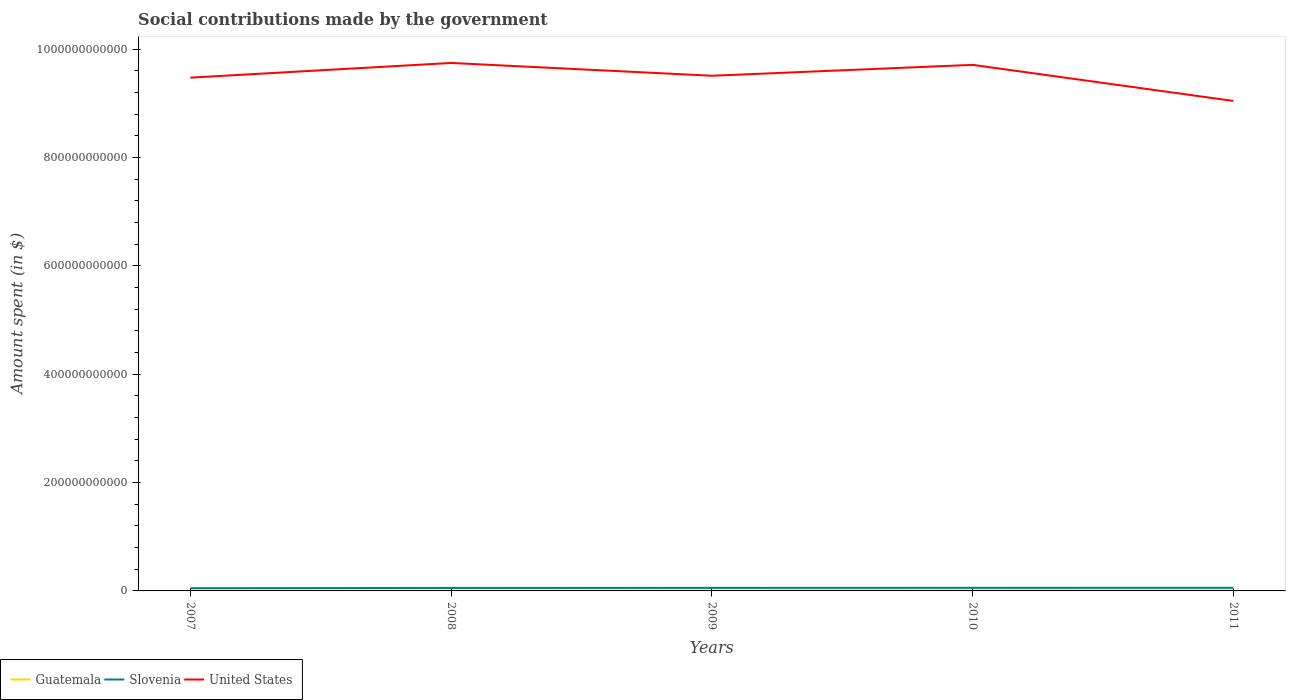How many different coloured lines are there?
Your answer should be compact. 3. Across all years, what is the maximum amount spent on social contributions in Guatemala?
Your response must be concise. 6.59e+08. In which year was the amount spent on social contributions in Slovenia maximum?
Your answer should be very brief. 2007. What is the total amount spent on social contributions in United States in the graph?
Provide a short and direct response. 6.66e+1. What is the difference between the highest and the second highest amount spent on social contributions in Guatemala?
Provide a short and direct response. 5.56e+08. Is the amount spent on social contributions in Slovenia strictly greater than the amount spent on social contributions in Guatemala over the years?
Give a very brief answer. No. What is the difference between two consecutive major ticks on the Y-axis?
Your answer should be compact. 2.00e+11. Does the graph contain any zero values?
Keep it short and to the point. No. Does the graph contain grids?
Provide a succinct answer. No. Where does the legend appear in the graph?
Make the answer very short. Bottom left. How are the legend labels stacked?
Your response must be concise. Horizontal. What is the title of the graph?
Provide a short and direct response. Social contributions made by the government. Does "Latin America(all income levels)" appear as one of the legend labels in the graph?
Your response must be concise. No. What is the label or title of the Y-axis?
Provide a short and direct response. Amount spent (in $). What is the Amount spent (in $) in Guatemala in 2007?
Provide a succinct answer. 6.59e+08. What is the Amount spent (in $) in Slovenia in 2007?
Your answer should be compact. 5.00e+09. What is the Amount spent (in $) in United States in 2007?
Ensure brevity in your answer.  9.47e+11. What is the Amount spent (in $) of Guatemala in 2008?
Provide a short and direct response. 7.46e+08. What is the Amount spent (in $) in Slovenia in 2008?
Your answer should be very brief. 5.53e+09. What is the Amount spent (in $) in United States in 2008?
Provide a short and direct response. 9.74e+11. What is the Amount spent (in $) of Guatemala in 2009?
Your answer should be compact. 9.22e+08. What is the Amount spent (in $) of Slovenia in 2009?
Provide a short and direct response. 5.64e+09. What is the Amount spent (in $) in United States in 2009?
Provide a succinct answer. 9.51e+11. What is the Amount spent (in $) in Guatemala in 2010?
Give a very brief answer. 1.07e+09. What is the Amount spent (in $) in Slovenia in 2010?
Offer a very short reply. 5.74e+09. What is the Amount spent (in $) in United States in 2010?
Provide a succinct answer. 9.71e+11. What is the Amount spent (in $) in Guatemala in 2011?
Make the answer very short. 1.21e+09. What is the Amount spent (in $) of Slovenia in 2011?
Ensure brevity in your answer.  5.78e+09. What is the Amount spent (in $) of United States in 2011?
Your answer should be compact. 9.04e+11. Across all years, what is the maximum Amount spent (in $) in Guatemala?
Ensure brevity in your answer.  1.21e+09. Across all years, what is the maximum Amount spent (in $) of Slovenia?
Give a very brief answer. 5.78e+09. Across all years, what is the maximum Amount spent (in $) in United States?
Offer a terse response. 9.74e+11. Across all years, what is the minimum Amount spent (in $) in Guatemala?
Your response must be concise. 6.59e+08. Across all years, what is the minimum Amount spent (in $) of Slovenia?
Offer a very short reply. 5.00e+09. Across all years, what is the minimum Amount spent (in $) in United States?
Ensure brevity in your answer.  9.04e+11. What is the total Amount spent (in $) of Guatemala in the graph?
Offer a very short reply. 4.61e+09. What is the total Amount spent (in $) in Slovenia in the graph?
Your response must be concise. 2.77e+1. What is the total Amount spent (in $) in United States in the graph?
Keep it short and to the point. 4.75e+12. What is the difference between the Amount spent (in $) of Guatemala in 2007 and that in 2008?
Offer a terse response. -8.79e+07. What is the difference between the Amount spent (in $) in Slovenia in 2007 and that in 2008?
Give a very brief answer. -5.23e+08. What is the difference between the Amount spent (in $) of United States in 2007 and that in 2008?
Your response must be concise. -2.71e+1. What is the difference between the Amount spent (in $) in Guatemala in 2007 and that in 2009?
Provide a succinct answer. -2.64e+08. What is the difference between the Amount spent (in $) of Slovenia in 2007 and that in 2009?
Provide a short and direct response. -6.35e+08. What is the difference between the Amount spent (in $) in United States in 2007 and that in 2009?
Your answer should be very brief. -3.50e+09. What is the difference between the Amount spent (in $) in Guatemala in 2007 and that in 2010?
Make the answer very short. -4.10e+08. What is the difference between the Amount spent (in $) in Slovenia in 2007 and that in 2010?
Offer a terse response. -7.35e+08. What is the difference between the Amount spent (in $) of United States in 2007 and that in 2010?
Your answer should be compact. -2.36e+1. What is the difference between the Amount spent (in $) in Guatemala in 2007 and that in 2011?
Give a very brief answer. -5.56e+08. What is the difference between the Amount spent (in $) of Slovenia in 2007 and that in 2011?
Make the answer very short. -7.79e+08. What is the difference between the Amount spent (in $) in United States in 2007 and that in 2011?
Your response must be concise. 4.30e+1. What is the difference between the Amount spent (in $) of Guatemala in 2008 and that in 2009?
Provide a succinct answer. -1.76e+08. What is the difference between the Amount spent (in $) of Slovenia in 2008 and that in 2009?
Give a very brief answer. -1.11e+08. What is the difference between the Amount spent (in $) in United States in 2008 and that in 2009?
Offer a very short reply. 2.36e+1. What is the difference between the Amount spent (in $) in Guatemala in 2008 and that in 2010?
Your answer should be compact. -3.23e+08. What is the difference between the Amount spent (in $) in Slovenia in 2008 and that in 2010?
Your answer should be very brief. -2.11e+08. What is the difference between the Amount spent (in $) of United States in 2008 and that in 2010?
Your answer should be compact. 3.50e+09. What is the difference between the Amount spent (in $) in Guatemala in 2008 and that in 2011?
Your response must be concise. -4.68e+08. What is the difference between the Amount spent (in $) in Slovenia in 2008 and that in 2011?
Your answer should be very brief. -2.56e+08. What is the difference between the Amount spent (in $) in United States in 2008 and that in 2011?
Make the answer very short. 7.01e+1. What is the difference between the Amount spent (in $) of Guatemala in 2009 and that in 2010?
Your response must be concise. -1.47e+08. What is the difference between the Amount spent (in $) in Slovenia in 2009 and that in 2010?
Provide a short and direct response. -9.99e+07. What is the difference between the Amount spent (in $) of United States in 2009 and that in 2010?
Provide a short and direct response. -2.01e+1. What is the difference between the Amount spent (in $) in Guatemala in 2009 and that in 2011?
Your response must be concise. -2.92e+08. What is the difference between the Amount spent (in $) in Slovenia in 2009 and that in 2011?
Provide a short and direct response. -1.44e+08. What is the difference between the Amount spent (in $) in United States in 2009 and that in 2011?
Your answer should be compact. 4.65e+1. What is the difference between the Amount spent (in $) of Guatemala in 2010 and that in 2011?
Keep it short and to the point. -1.45e+08. What is the difference between the Amount spent (in $) in Slovenia in 2010 and that in 2011?
Your response must be concise. -4.46e+07. What is the difference between the Amount spent (in $) of United States in 2010 and that in 2011?
Keep it short and to the point. 6.66e+1. What is the difference between the Amount spent (in $) in Guatemala in 2007 and the Amount spent (in $) in Slovenia in 2008?
Make the answer very short. -4.87e+09. What is the difference between the Amount spent (in $) in Guatemala in 2007 and the Amount spent (in $) in United States in 2008?
Give a very brief answer. -9.74e+11. What is the difference between the Amount spent (in $) of Slovenia in 2007 and the Amount spent (in $) of United States in 2008?
Your answer should be very brief. -9.69e+11. What is the difference between the Amount spent (in $) in Guatemala in 2007 and the Amount spent (in $) in Slovenia in 2009?
Give a very brief answer. -4.98e+09. What is the difference between the Amount spent (in $) of Guatemala in 2007 and the Amount spent (in $) of United States in 2009?
Provide a short and direct response. -9.50e+11. What is the difference between the Amount spent (in $) in Slovenia in 2007 and the Amount spent (in $) in United States in 2009?
Ensure brevity in your answer.  -9.46e+11. What is the difference between the Amount spent (in $) in Guatemala in 2007 and the Amount spent (in $) in Slovenia in 2010?
Keep it short and to the point. -5.08e+09. What is the difference between the Amount spent (in $) in Guatemala in 2007 and the Amount spent (in $) in United States in 2010?
Your answer should be very brief. -9.70e+11. What is the difference between the Amount spent (in $) of Slovenia in 2007 and the Amount spent (in $) of United States in 2010?
Provide a succinct answer. -9.66e+11. What is the difference between the Amount spent (in $) in Guatemala in 2007 and the Amount spent (in $) in Slovenia in 2011?
Make the answer very short. -5.12e+09. What is the difference between the Amount spent (in $) in Guatemala in 2007 and the Amount spent (in $) in United States in 2011?
Provide a succinct answer. -9.04e+11. What is the difference between the Amount spent (in $) of Slovenia in 2007 and the Amount spent (in $) of United States in 2011?
Keep it short and to the point. -8.99e+11. What is the difference between the Amount spent (in $) in Guatemala in 2008 and the Amount spent (in $) in Slovenia in 2009?
Offer a terse response. -4.89e+09. What is the difference between the Amount spent (in $) of Guatemala in 2008 and the Amount spent (in $) of United States in 2009?
Ensure brevity in your answer.  -9.50e+11. What is the difference between the Amount spent (in $) of Slovenia in 2008 and the Amount spent (in $) of United States in 2009?
Provide a short and direct response. -9.45e+11. What is the difference between the Amount spent (in $) in Guatemala in 2008 and the Amount spent (in $) in Slovenia in 2010?
Ensure brevity in your answer.  -4.99e+09. What is the difference between the Amount spent (in $) of Guatemala in 2008 and the Amount spent (in $) of United States in 2010?
Offer a terse response. -9.70e+11. What is the difference between the Amount spent (in $) of Slovenia in 2008 and the Amount spent (in $) of United States in 2010?
Keep it short and to the point. -9.65e+11. What is the difference between the Amount spent (in $) in Guatemala in 2008 and the Amount spent (in $) in Slovenia in 2011?
Your answer should be very brief. -5.03e+09. What is the difference between the Amount spent (in $) of Guatemala in 2008 and the Amount spent (in $) of United States in 2011?
Offer a terse response. -9.04e+11. What is the difference between the Amount spent (in $) in Slovenia in 2008 and the Amount spent (in $) in United States in 2011?
Make the answer very short. -8.99e+11. What is the difference between the Amount spent (in $) in Guatemala in 2009 and the Amount spent (in $) in Slovenia in 2010?
Give a very brief answer. -4.81e+09. What is the difference between the Amount spent (in $) in Guatemala in 2009 and the Amount spent (in $) in United States in 2010?
Ensure brevity in your answer.  -9.70e+11. What is the difference between the Amount spent (in $) of Slovenia in 2009 and the Amount spent (in $) of United States in 2010?
Offer a terse response. -9.65e+11. What is the difference between the Amount spent (in $) in Guatemala in 2009 and the Amount spent (in $) in Slovenia in 2011?
Your answer should be compact. -4.86e+09. What is the difference between the Amount spent (in $) of Guatemala in 2009 and the Amount spent (in $) of United States in 2011?
Offer a very short reply. -9.03e+11. What is the difference between the Amount spent (in $) in Slovenia in 2009 and the Amount spent (in $) in United States in 2011?
Provide a succinct answer. -8.99e+11. What is the difference between the Amount spent (in $) in Guatemala in 2010 and the Amount spent (in $) in Slovenia in 2011?
Offer a terse response. -4.71e+09. What is the difference between the Amount spent (in $) of Guatemala in 2010 and the Amount spent (in $) of United States in 2011?
Your response must be concise. -9.03e+11. What is the difference between the Amount spent (in $) of Slovenia in 2010 and the Amount spent (in $) of United States in 2011?
Ensure brevity in your answer.  -8.99e+11. What is the average Amount spent (in $) in Guatemala per year?
Make the answer very short. 9.22e+08. What is the average Amount spent (in $) of Slovenia per year?
Keep it short and to the point. 5.54e+09. What is the average Amount spent (in $) in United States per year?
Offer a very short reply. 9.50e+11. In the year 2007, what is the difference between the Amount spent (in $) in Guatemala and Amount spent (in $) in Slovenia?
Your answer should be compact. -4.34e+09. In the year 2007, what is the difference between the Amount spent (in $) of Guatemala and Amount spent (in $) of United States?
Provide a succinct answer. -9.47e+11. In the year 2007, what is the difference between the Amount spent (in $) of Slovenia and Amount spent (in $) of United States?
Keep it short and to the point. -9.42e+11. In the year 2008, what is the difference between the Amount spent (in $) in Guatemala and Amount spent (in $) in Slovenia?
Provide a short and direct response. -4.78e+09. In the year 2008, what is the difference between the Amount spent (in $) of Guatemala and Amount spent (in $) of United States?
Your response must be concise. -9.74e+11. In the year 2008, what is the difference between the Amount spent (in $) in Slovenia and Amount spent (in $) in United States?
Your answer should be compact. -9.69e+11. In the year 2009, what is the difference between the Amount spent (in $) of Guatemala and Amount spent (in $) of Slovenia?
Provide a succinct answer. -4.71e+09. In the year 2009, what is the difference between the Amount spent (in $) in Guatemala and Amount spent (in $) in United States?
Offer a very short reply. -9.50e+11. In the year 2009, what is the difference between the Amount spent (in $) in Slovenia and Amount spent (in $) in United States?
Ensure brevity in your answer.  -9.45e+11. In the year 2010, what is the difference between the Amount spent (in $) in Guatemala and Amount spent (in $) in Slovenia?
Provide a succinct answer. -4.67e+09. In the year 2010, what is the difference between the Amount spent (in $) of Guatemala and Amount spent (in $) of United States?
Provide a succinct answer. -9.70e+11. In the year 2010, what is the difference between the Amount spent (in $) in Slovenia and Amount spent (in $) in United States?
Provide a short and direct response. -9.65e+11. In the year 2011, what is the difference between the Amount spent (in $) of Guatemala and Amount spent (in $) of Slovenia?
Keep it short and to the point. -4.57e+09. In the year 2011, what is the difference between the Amount spent (in $) of Guatemala and Amount spent (in $) of United States?
Keep it short and to the point. -9.03e+11. In the year 2011, what is the difference between the Amount spent (in $) in Slovenia and Amount spent (in $) in United States?
Your response must be concise. -8.99e+11. What is the ratio of the Amount spent (in $) of Guatemala in 2007 to that in 2008?
Ensure brevity in your answer.  0.88. What is the ratio of the Amount spent (in $) in Slovenia in 2007 to that in 2008?
Make the answer very short. 0.91. What is the ratio of the Amount spent (in $) in United States in 2007 to that in 2008?
Ensure brevity in your answer.  0.97. What is the ratio of the Amount spent (in $) of Guatemala in 2007 to that in 2009?
Your answer should be very brief. 0.71. What is the ratio of the Amount spent (in $) in Slovenia in 2007 to that in 2009?
Your answer should be compact. 0.89. What is the ratio of the Amount spent (in $) of United States in 2007 to that in 2009?
Provide a succinct answer. 1. What is the ratio of the Amount spent (in $) of Guatemala in 2007 to that in 2010?
Keep it short and to the point. 0.62. What is the ratio of the Amount spent (in $) of Slovenia in 2007 to that in 2010?
Ensure brevity in your answer.  0.87. What is the ratio of the Amount spent (in $) of United States in 2007 to that in 2010?
Give a very brief answer. 0.98. What is the ratio of the Amount spent (in $) of Guatemala in 2007 to that in 2011?
Offer a terse response. 0.54. What is the ratio of the Amount spent (in $) in Slovenia in 2007 to that in 2011?
Your answer should be very brief. 0.87. What is the ratio of the Amount spent (in $) in United States in 2007 to that in 2011?
Keep it short and to the point. 1.05. What is the ratio of the Amount spent (in $) of Guatemala in 2008 to that in 2009?
Provide a succinct answer. 0.81. What is the ratio of the Amount spent (in $) in Slovenia in 2008 to that in 2009?
Ensure brevity in your answer.  0.98. What is the ratio of the Amount spent (in $) in United States in 2008 to that in 2009?
Ensure brevity in your answer.  1.02. What is the ratio of the Amount spent (in $) of Guatemala in 2008 to that in 2010?
Offer a very short reply. 0.7. What is the ratio of the Amount spent (in $) in Slovenia in 2008 to that in 2010?
Offer a very short reply. 0.96. What is the ratio of the Amount spent (in $) of Guatemala in 2008 to that in 2011?
Make the answer very short. 0.61. What is the ratio of the Amount spent (in $) of Slovenia in 2008 to that in 2011?
Keep it short and to the point. 0.96. What is the ratio of the Amount spent (in $) of United States in 2008 to that in 2011?
Provide a succinct answer. 1.08. What is the ratio of the Amount spent (in $) in Guatemala in 2009 to that in 2010?
Provide a short and direct response. 0.86. What is the ratio of the Amount spent (in $) in Slovenia in 2009 to that in 2010?
Provide a short and direct response. 0.98. What is the ratio of the Amount spent (in $) of United States in 2009 to that in 2010?
Your response must be concise. 0.98. What is the ratio of the Amount spent (in $) of Guatemala in 2009 to that in 2011?
Provide a succinct answer. 0.76. What is the ratio of the Amount spent (in $) of Slovenia in 2009 to that in 2011?
Provide a succinct answer. 0.97. What is the ratio of the Amount spent (in $) of United States in 2009 to that in 2011?
Provide a short and direct response. 1.05. What is the ratio of the Amount spent (in $) of Guatemala in 2010 to that in 2011?
Offer a terse response. 0.88. What is the ratio of the Amount spent (in $) of Slovenia in 2010 to that in 2011?
Give a very brief answer. 0.99. What is the ratio of the Amount spent (in $) in United States in 2010 to that in 2011?
Offer a very short reply. 1.07. What is the difference between the highest and the second highest Amount spent (in $) of Guatemala?
Provide a succinct answer. 1.45e+08. What is the difference between the highest and the second highest Amount spent (in $) of Slovenia?
Make the answer very short. 4.46e+07. What is the difference between the highest and the second highest Amount spent (in $) of United States?
Provide a succinct answer. 3.50e+09. What is the difference between the highest and the lowest Amount spent (in $) of Guatemala?
Offer a very short reply. 5.56e+08. What is the difference between the highest and the lowest Amount spent (in $) of Slovenia?
Give a very brief answer. 7.79e+08. What is the difference between the highest and the lowest Amount spent (in $) in United States?
Your answer should be compact. 7.01e+1. 